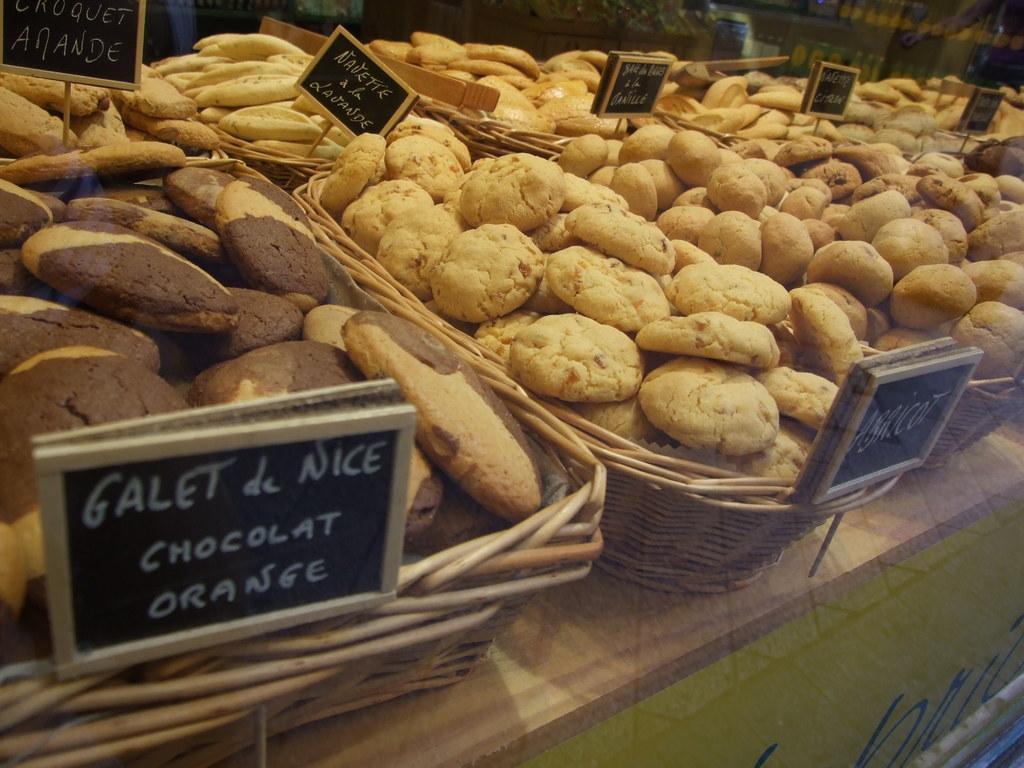Could you give a brief overview of what you see in this image? In this picture, we see the baskets containing the cookies are placed on the table. We see the placards in black color with some text written on it. In the right bottom, we see a wall in green color. 